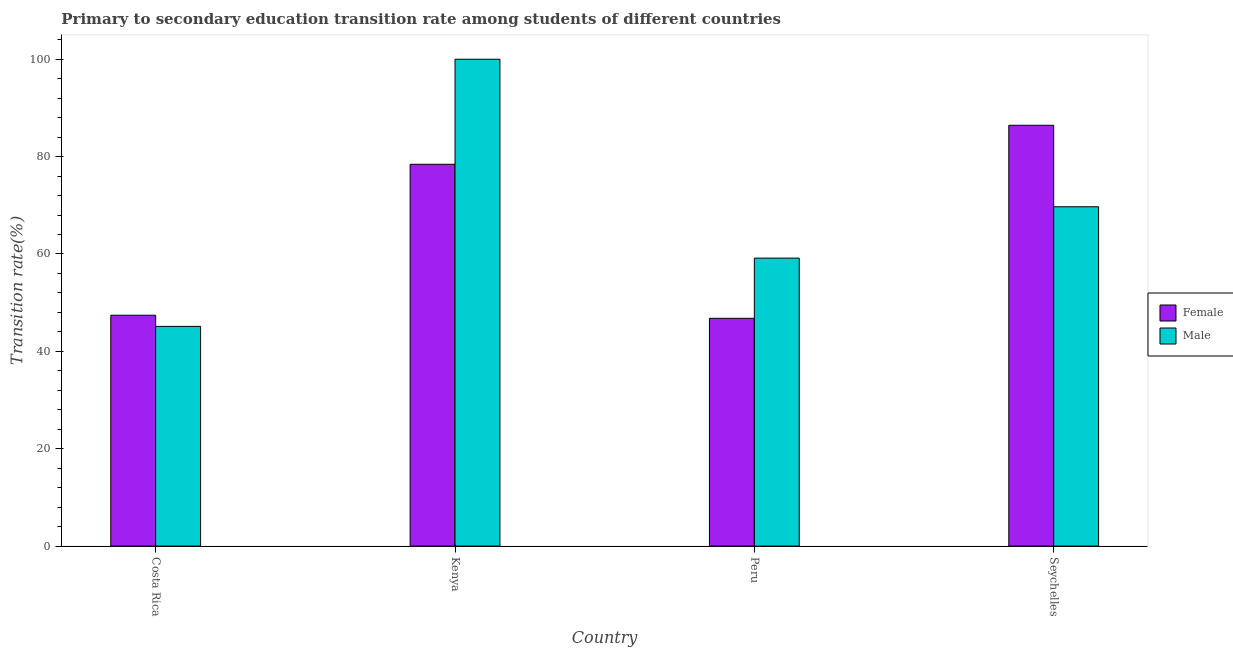How many groups of bars are there?
Make the answer very short. 4. How many bars are there on the 3rd tick from the left?
Offer a very short reply. 2. What is the label of the 2nd group of bars from the left?
Make the answer very short. Kenya. In how many cases, is the number of bars for a given country not equal to the number of legend labels?
Offer a very short reply. 0. What is the transition rate among female students in Costa Rica?
Ensure brevity in your answer.  47.42. Across all countries, what is the minimum transition rate among female students?
Make the answer very short. 46.79. In which country was the transition rate among male students maximum?
Ensure brevity in your answer.  Kenya. What is the total transition rate among male students in the graph?
Your answer should be very brief. 273.97. What is the difference between the transition rate among male students in Kenya and that in Seychelles?
Your answer should be compact. 30.3. What is the difference between the transition rate among male students in Seychelles and the transition rate among female students in Peru?
Keep it short and to the point. 22.91. What is the average transition rate among female students per country?
Offer a very short reply. 64.77. What is the difference between the transition rate among male students and transition rate among female students in Costa Rica?
Your response must be concise. -2.29. In how many countries, is the transition rate among male students greater than 44 %?
Your answer should be very brief. 4. What is the ratio of the transition rate among female students in Costa Rica to that in Peru?
Make the answer very short. 1.01. Is the transition rate among male students in Costa Rica less than that in Peru?
Offer a very short reply. Yes. Is the difference between the transition rate among female students in Costa Rica and Seychelles greater than the difference between the transition rate among male students in Costa Rica and Seychelles?
Give a very brief answer. No. What is the difference between the highest and the second highest transition rate among female students?
Your response must be concise. 8.01. What is the difference between the highest and the lowest transition rate among female students?
Keep it short and to the point. 39.64. Is the sum of the transition rate among male students in Kenya and Seychelles greater than the maximum transition rate among female students across all countries?
Offer a terse response. Yes. What does the 2nd bar from the right in Costa Rica represents?
Offer a very short reply. Female. Are all the bars in the graph horizontal?
Provide a short and direct response. No. How many countries are there in the graph?
Make the answer very short. 4. What is the difference between two consecutive major ticks on the Y-axis?
Offer a terse response. 20. Are the values on the major ticks of Y-axis written in scientific E-notation?
Your answer should be very brief. No. Does the graph contain any zero values?
Provide a short and direct response. No. Where does the legend appear in the graph?
Provide a short and direct response. Center right. How many legend labels are there?
Give a very brief answer. 2. How are the legend labels stacked?
Provide a short and direct response. Vertical. What is the title of the graph?
Ensure brevity in your answer.  Primary to secondary education transition rate among students of different countries. Does "Food and tobacco" appear as one of the legend labels in the graph?
Your answer should be very brief. No. What is the label or title of the Y-axis?
Your answer should be very brief. Transition rate(%). What is the Transition rate(%) in Female in Costa Rica?
Your answer should be very brief. 47.42. What is the Transition rate(%) of Male in Costa Rica?
Provide a short and direct response. 45.13. What is the Transition rate(%) in Female in Kenya?
Give a very brief answer. 78.42. What is the Transition rate(%) of Male in Kenya?
Your answer should be very brief. 100. What is the Transition rate(%) in Female in Peru?
Your answer should be compact. 46.79. What is the Transition rate(%) of Male in Peru?
Make the answer very short. 59.15. What is the Transition rate(%) in Female in Seychelles?
Offer a terse response. 86.43. What is the Transition rate(%) of Male in Seychelles?
Offer a terse response. 69.7. Across all countries, what is the maximum Transition rate(%) in Female?
Your response must be concise. 86.43. Across all countries, what is the minimum Transition rate(%) of Female?
Give a very brief answer. 46.79. Across all countries, what is the minimum Transition rate(%) in Male?
Keep it short and to the point. 45.13. What is the total Transition rate(%) in Female in the graph?
Make the answer very short. 259.06. What is the total Transition rate(%) in Male in the graph?
Provide a short and direct response. 273.97. What is the difference between the Transition rate(%) of Female in Costa Rica and that in Kenya?
Your answer should be compact. -31.01. What is the difference between the Transition rate(%) in Male in Costa Rica and that in Kenya?
Offer a terse response. -54.88. What is the difference between the Transition rate(%) in Female in Costa Rica and that in Peru?
Offer a very short reply. 0.63. What is the difference between the Transition rate(%) of Male in Costa Rica and that in Peru?
Your response must be concise. -14.02. What is the difference between the Transition rate(%) in Female in Costa Rica and that in Seychelles?
Keep it short and to the point. -39.01. What is the difference between the Transition rate(%) in Male in Costa Rica and that in Seychelles?
Provide a short and direct response. -24.57. What is the difference between the Transition rate(%) of Female in Kenya and that in Peru?
Offer a very short reply. 31.64. What is the difference between the Transition rate(%) of Male in Kenya and that in Peru?
Offer a terse response. 40.85. What is the difference between the Transition rate(%) of Female in Kenya and that in Seychelles?
Provide a succinct answer. -8.01. What is the difference between the Transition rate(%) in Male in Kenya and that in Seychelles?
Make the answer very short. 30.3. What is the difference between the Transition rate(%) in Female in Peru and that in Seychelles?
Provide a short and direct response. -39.64. What is the difference between the Transition rate(%) of Male in Peru and that in Seychelles?
Offer a terse response. -10.55. What is the difference between the Transition rate(%) of Female in Costa Rica and the Transition rate(%) of Male in Kenya?
Ensure brevity in your answer.  -52.58. What is the difference between the Transition rate(%) in Female in Costa Rica and the Transition rate(%) in Male in Peru?
Give a very brief answer. -11.73. What is the difference between the Transition rate(%) in Female in Costa Rica and the Transition rate(%) in Male in Seychelles?
Your response must be concise. -22.28. What is the difference between the Transition rate(%) in Female in Kenya and the Transition rate(%) in Male in Peru?
Your response must be concise. 19.28. What is the difference between the Transition rate(%) in Female in Kenya and the Transition rate(%) in Male in Seychelles?
Your answer should be compact. 8.73. What is the difference between the Transition rate(%) of Female in Peru and the Transition rate(%) of Male in Seychelles?
Ensure brevity in your answer.  -22.91. What is the average Transition rate(%) of Female per country?
Ensure brevity in your answer.  64.77. What is the average Transition rate(%) of Male per country?
Offer a terse response. 68.49. What is the difference between the Transition rate(%) in Female and Transition rate(%) in Male in Costa Rica?
Ensure brevity in your answer.  2.29. What is the difference between the Transition rate(%) in Female and Transition rate(%) in Male in Kenya?
Your response must be concise. -21.58. What is the difference between the Transition rate(%) of Female and Transition rate(%) of Male in Peru?
Your response must be concise. -12.36. What is the difference between the Transition rate(%) in Female and Transition rate(%) in Male in Seychelles?
Your response must be concise. 16.74. What is the ratio of the Transition rate(%) of Female in Costa Rica to that in Kenya?
Ensure brevity in your answer.  0.6. What is the ratio of the Transition rate(%) of Male in Costa Rica to that in Kenya?
Offer a terse response. 0.45. What is the ratio of the Transition rate(%) in Female in Costa Rica to that in Peru?
Your answer should be compact. 1.01. What is the ratio of the Transition rate(%) of Male in Costa Rica to that in Peru?
Offer a terse response. 0.76. What is the ratio of the Transition rate(%) of Female in Costa Rica to that in Seychelles?
Ensure brevity in your answer.  0.55. What is the ratio of the Transition rate(%) of Male in Costa Rica to that in Seychelles?
Make the answer very short. 0.65. What is the ratio of the Transition rate(%) in Female in Kenya to that in Peru?
Provide a succinct answer. 1.68. What is the ratio of the Transition rate(%) of Male in Kenya to that in Peru?
Your answer should be compact. 1.69. What is the ratio of the Transition rate(%) of Female in Kenya to that in Seychelles?
Your answer should be very brief. 0.91. What is the ratio of the Transition rate(%) in Male in Kenya to that in Seychelles?
Your answer should be compact. 1.43. What is the ratio of the Transition rate(%) in Female in Peru to that in Seychelles?
Keep it short and to the point. 0.54. What is the ratio of the Transition rate(%) in Male in Peru to that in Seychelles?
Give a very brief answer. 0.85. What is the difference between the highest and the second highest Transition rate(%) of Female?
Give a very brief answer. 8.01. What is the difference between the highest and the second highest Transition rate(%) in Male?
Give a very brief answer. 30.3. What is the difference between the highest and the lowest Transition rate(%) in Female?
Your answer should be very brief. 39.64. What is the difference between the highest and the lowest Transition rate(%) of Male?
Ensure brevity in your answer.  54.88. 